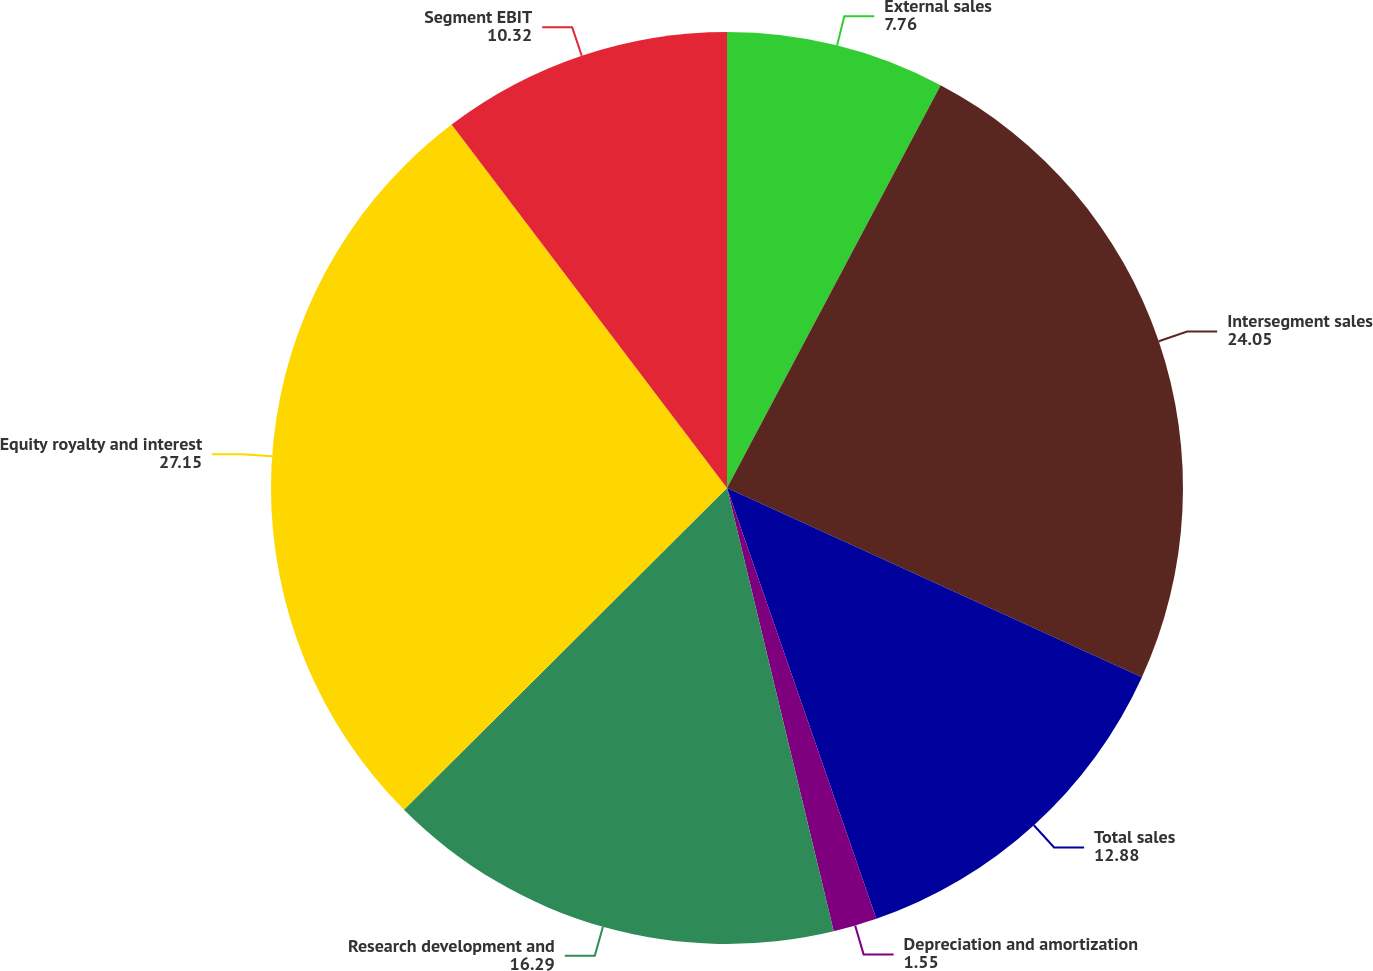Convert chart. <chart><loc_0><loc_0><loc_500><loc_500><pie_chart><fcel>External sales<fcel>Intersegment sales<fcel>Total sales<fcel>Depreciation and amortization<fcel>Research development and<fcel>Equity royalty and interest<fcel>Segment EBIT<nl><fcel>7.76%<fcel>24.05%<fcel>12.88%<fcel>1.55%<fcel>16.29%<fcel>27.15%<fcel>10.32%<nl></chart> 